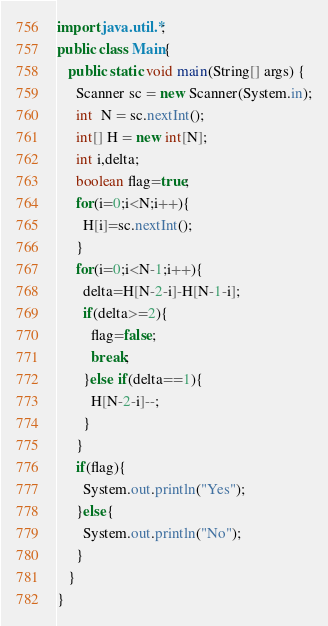<code> <loc_0><loc_0><loc_500><loc_500><_Java_>import java.util.*;
public class Main{
   public static void main(String[] args) {
     Scanner sc = new Scanner(System.in);
     int  N = sc.nextInt();
     int[] H = new int[N];
     int i,delta;
     boolean flag=true;
     for(i=0;i<N;i++){
       H[i]=sc.nextInt();
     }
     for(i=0;i<N-1;i++){
       delta=H[N-2-i]-H[N-1-i];
       if(delta>=2){
         flag=false;
         break;
       }else if(delta==1){
         H[N-2-i]--;
       }
     }
     if(flag){
       System.out.println("Yes");
     }else{
       System.out.println("No");
     }
   }
}
</code> 